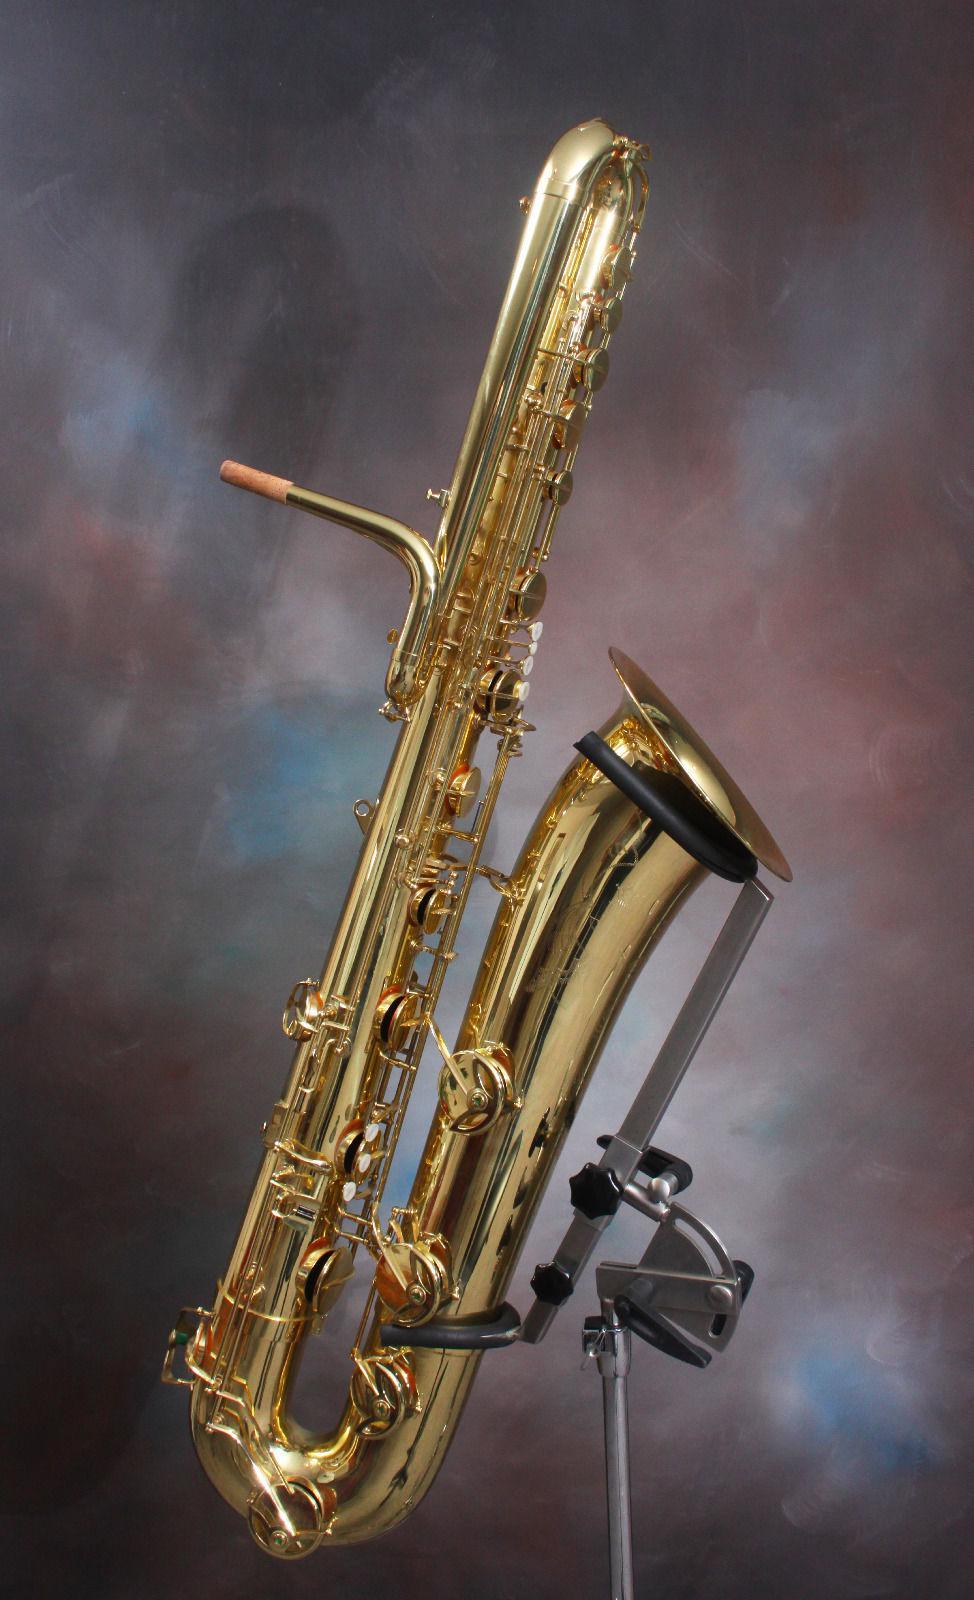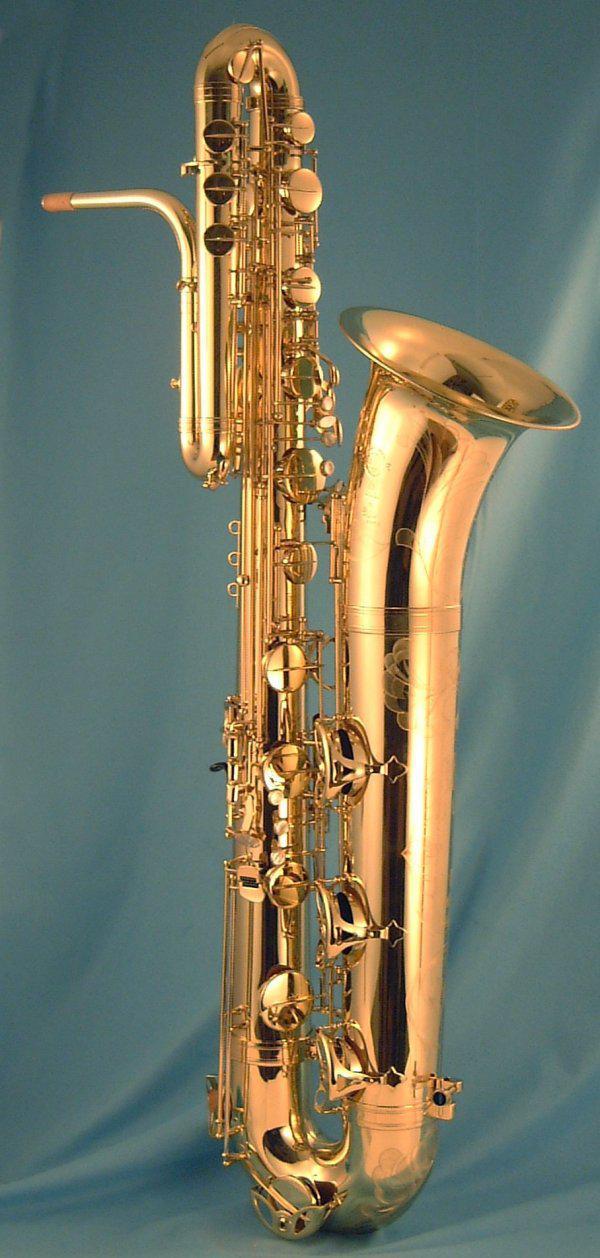The first image is the image on the left, the second image is the image on the right. For the images shown, is this caption "The left image features a saxophone on a stand tilting rightward." true? Answer yes or no. Yes. The first image is the image on the left, the second image is the image on the right. For the images displayed, is the sentence "At least one mouthpiece is black." factually correct? Answer yes or no. No. 